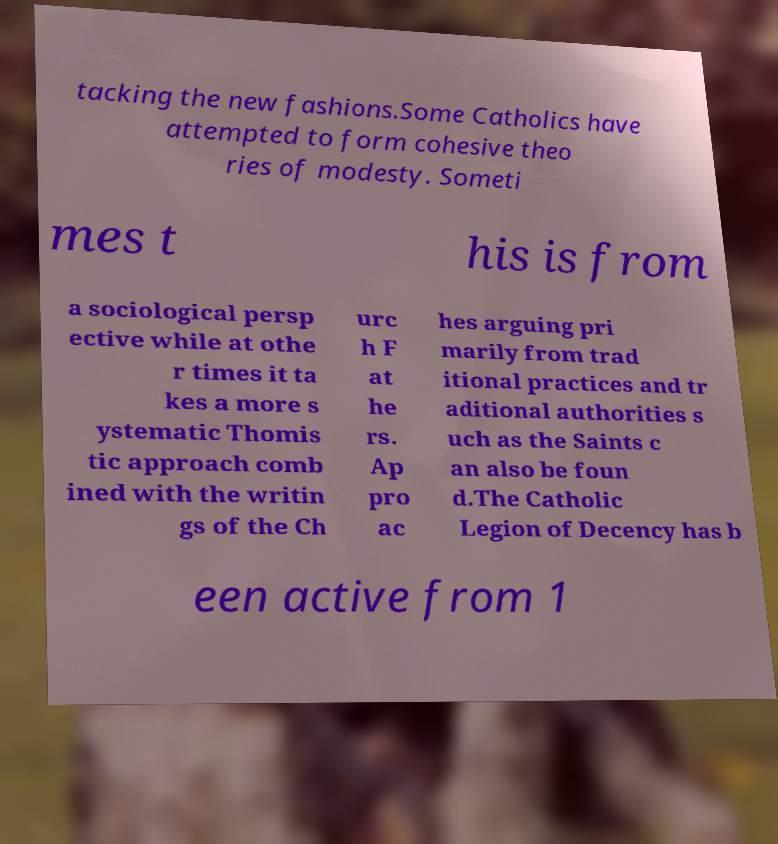Please identify and transcribe the text found in this image. tacking the new fashions.Some Catholics have attempted to form cohesive theo ries of modesty. Someti mes t his is from a sociological persp ective while at othe r times it ta kes a more s ystematic Thomis tic approach comb ined with the writin gs of the Ch urc h F at he rs. Ap pro ac hes arguing pri marily from trad itional practices and tr aditional authorities s uch as the Saints c an also be foun d.The Catholic Legion of Decency has b een active from 1 